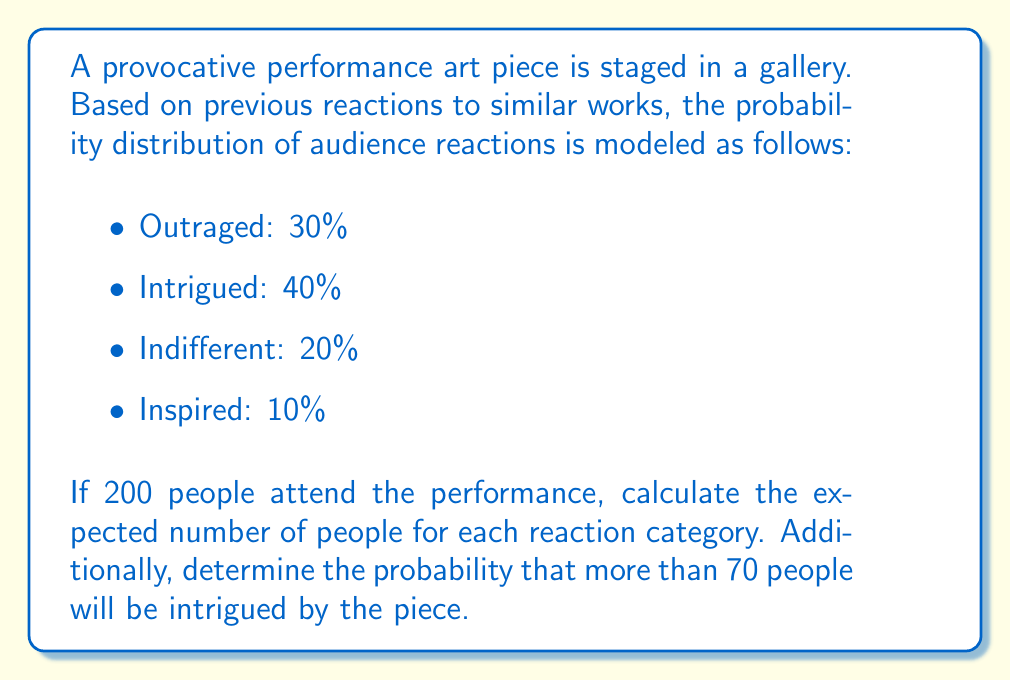Can you answer this question? 1. Expected number of people for each reaction:
   Let $N$ be the total number of attendees (200).
   For each category, multiply the probability by $N$:

   Outraged: $0.30 \times 200 = 60$
   Intrigued: $0.40 \times 200 = 80$
   Indifferent: $0.20 \times 200 = 40$
   Inspired: $0.10 \times 200 = 20$

2. Probability of more than 70 people being intrigued:
   This follows a binomial distribution with $n = 200$ and $p = 0.40$.
   We need to calculate $P(X > 70)$, where $X$ is the number of intrigued people.

   Using the normal approximation to the binomial distribution:
   
   Mean: $\mu = np = 200 \times 0.40 = 80$
   Standard deviation: $\sigma = \sqrt{np(1-p)} = \sqrt{200 \times 0.40 \times 0.60} = 6.93$

   Standardizing, we get:
   $$z = \frac{70.5 - 80}{6.93} = -1.37$$

   (We use 70.5 for continuity correction)

   Using a standard normal table or calculator, we find:
   $P(Z < -1.37) \approx 0.0853$

   Therefore, $P(X > 70) = 1 - 0.0853 = 0.9147$
Answer: Expected numbers: Outraged: 60, Intrigued: 80, Indifferent: 40, Inspired: 20. Probability of more than 70 intrigued: 0.9147 